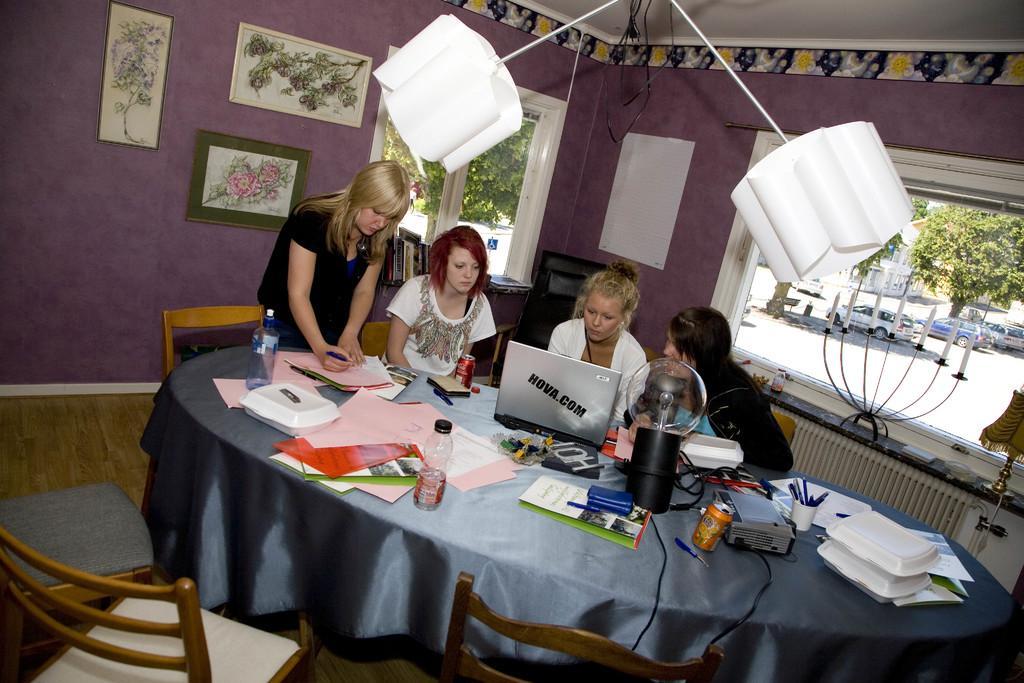In one or two sentences, can you explain what this image depicts? As we can see in the image, there is a wall, photo frames, window, trees, car and few people over here and there are chairs and tables. On table there is a laptop, books, papers and bottle. 